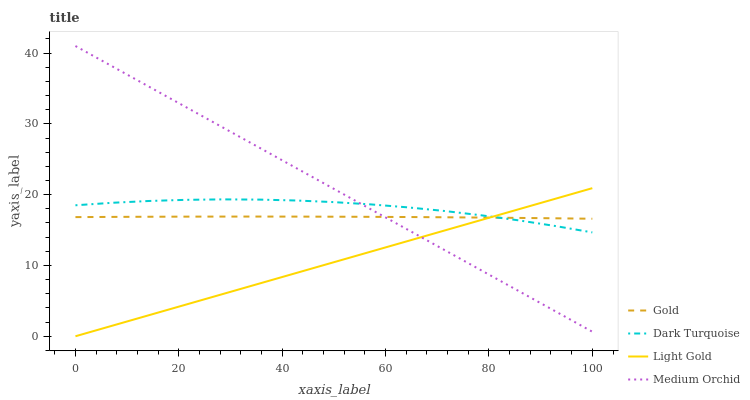Does Light Gold have the minimum area under the curve?
Answer yes or no. Yes. Does Medium Orchid have the maximum area under the curve?
Answer yes or no. Yes. Does Medium Orchid have the minimum area under the curve?
Answer yes or no. No. Does Light Gold have the maximum area under the curve?
Answer yes or no. No. Is Light Gold the smoothest?
Answer yes or no. Yes. Is Dark Turquoise the roughest?
Answer yes or no. Yes. Is Medium Orchid the smoothest?
Answer yes or no. No. Is Medium Orchid the roughest?
Answer yes or no. No. Does Light Gold have the lowest value?
Answer yes or no. Yes. Does Medium Orchid have the lowest value?
Answer yes or no. No. Does Medium Orchid have the highest value?
Answer yes or no. Yes. Does Light Gold have the highest value?
Answer yes or no. No. Does Dark Turquoise intersect Gold?
Answer yes or no. Yes. Is Dark Turquoise less than Gold?
Answer yes or no. No. Is Dark Turquoise greater than Gold?
Answer yes or no. No. 